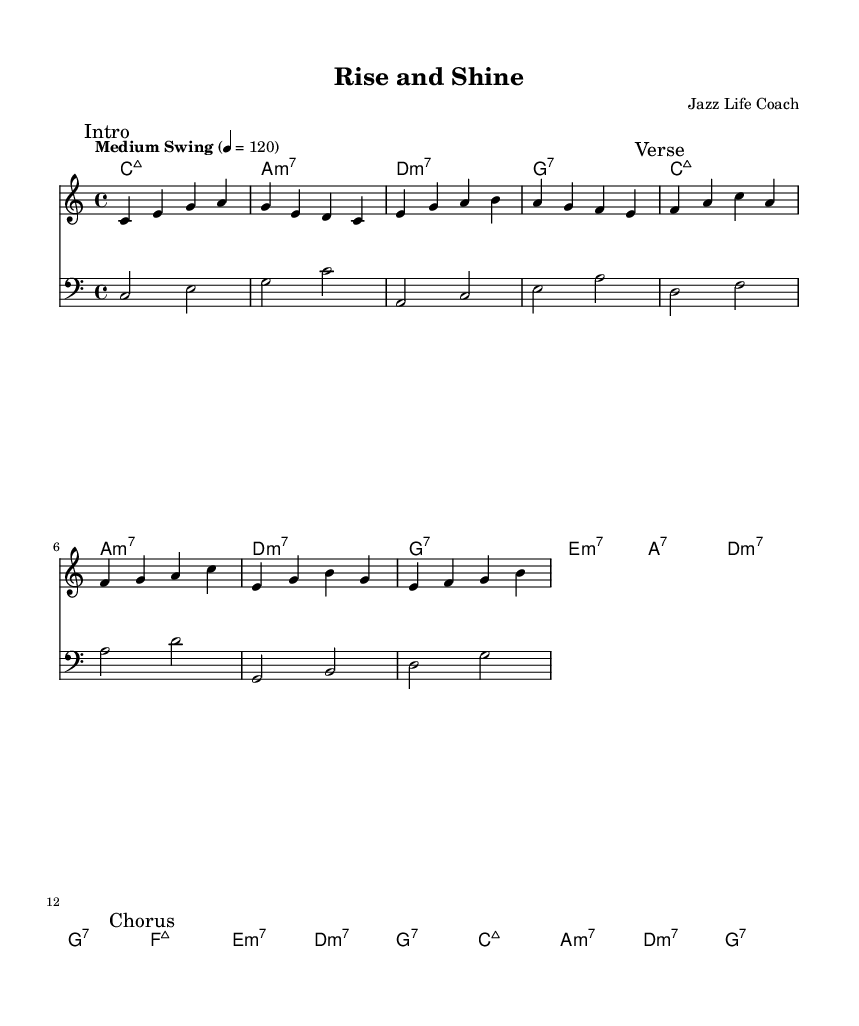What is the key signature of this music? The key signature is indicated at the beginning of the score and shows no sharps or flats, which means it is in C major.
Answer: C major What is the time signature of this music? The time signature is located at the start of the score and is represented as "4/4", meaning there are four beats in each measure and the quarter note gets one beat.
Answer: 4/4 What is the tempo marking for this piece? The tempo marking is supplied with the instruction "Medium Swing" and a metronome marking of 120 beats per minute indicates the pacing for the music.
Answer: Medium Swing How many measures are in the verse section? By counting the measures indicated in the verse section, which is marked in the score, we find there are eight measures in total in that section.
Answer: 8 What chord is played at the beginning of the chorus? The chorus section begins with the F major seventh chord, as indicated at the start of the chorus line.
Answer: F:maj7 Which section contains the motivational lyrics? The lyrics are placed throughout the score but are specifically noted in two sections, the verse and the chorus, both of which contain motivational themes.
Answer: Verse and Chorus What is the primary style of this musical piece? The overall feel or genre of the music, described in the context of swing rhythms and improvisational elements characteristic of jazz, leads to the conclusion that this piece exemplifies jazz fusion.
Answer: Jazz fusion 